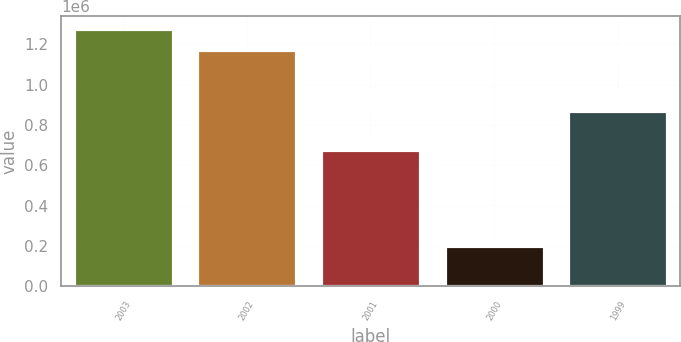Convert chart. <chart><loc_0><loc_0><loc_500><loc_500><bar_chart><fcel>2003<fcel>2002<fcel>2001<fcel>2000<fcel>1999<nl><fcel>1.27358e+06<fcel>1.1725e+06<fcel>674500<fcel>198600<fcel>868850<nl></chart> 